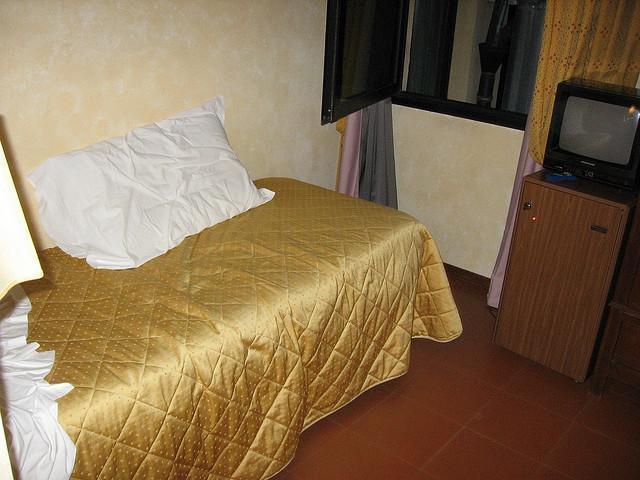How many red bikes are there?
Give a very brief answer. 0. 